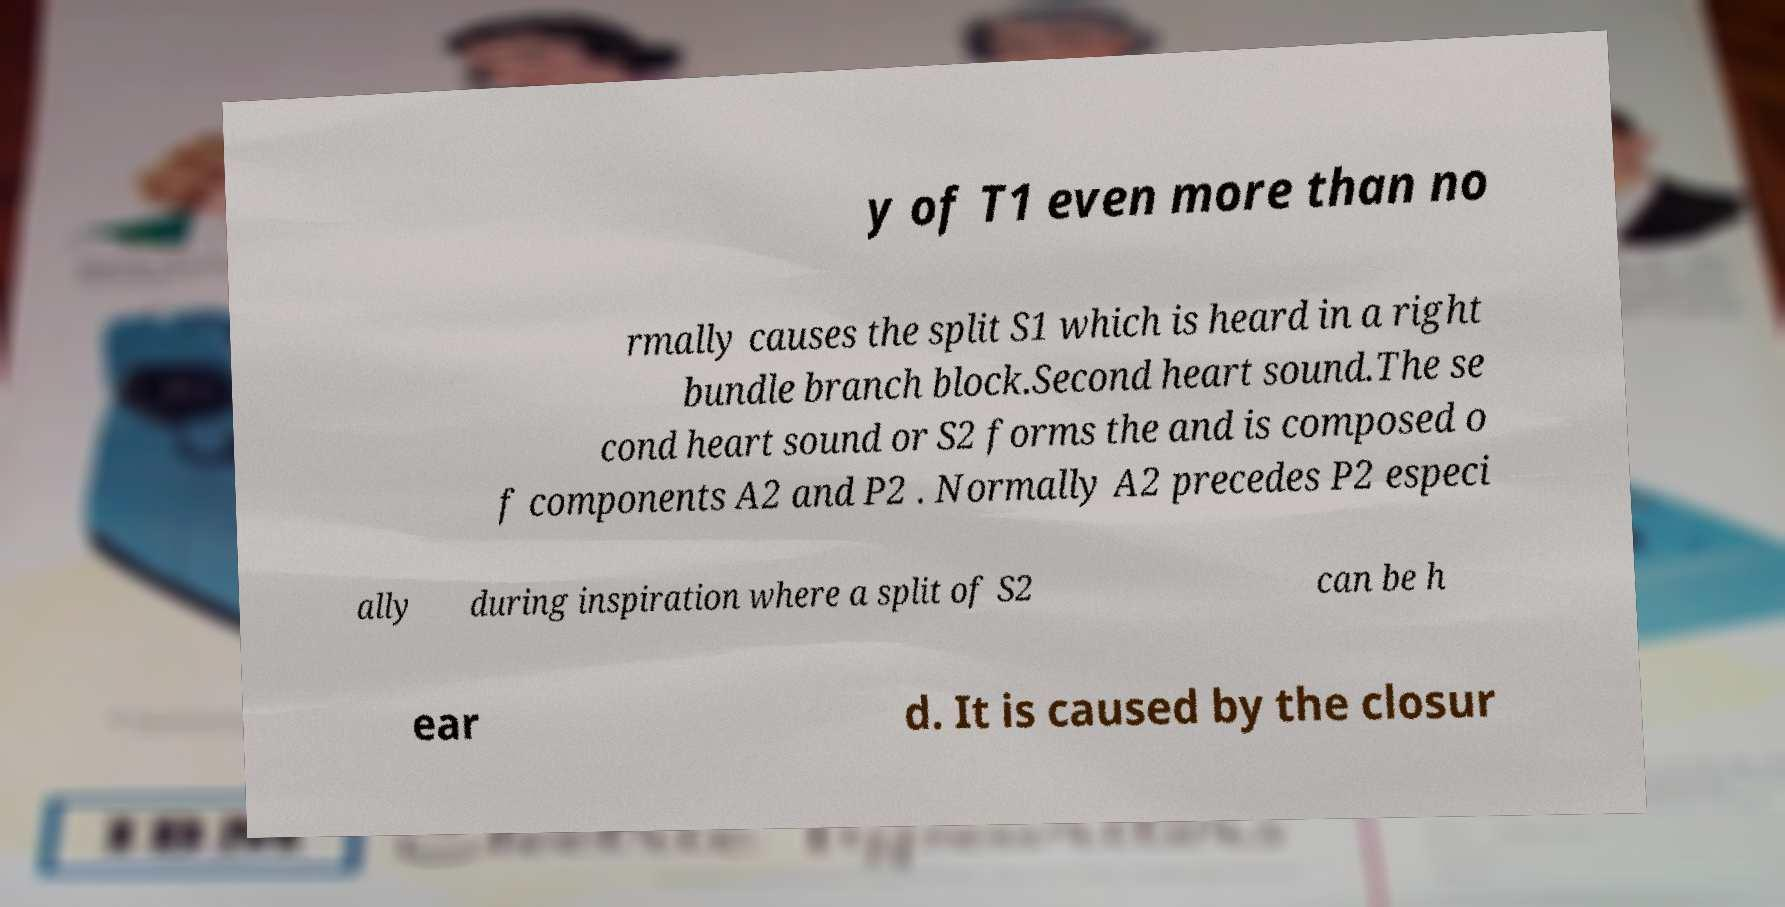Could you extract and type out the text from this image? y of T1 even more than no rmally causes the split S1 which is heard in a right bundle branch block.Second heart sound.The se cond heart sound or S2 forms the and is composed o f components A2 and P2 . Normally A2 precedes P2 especi ally during inspiration where a split of S2 can be h ear d. It is caused by the closur 